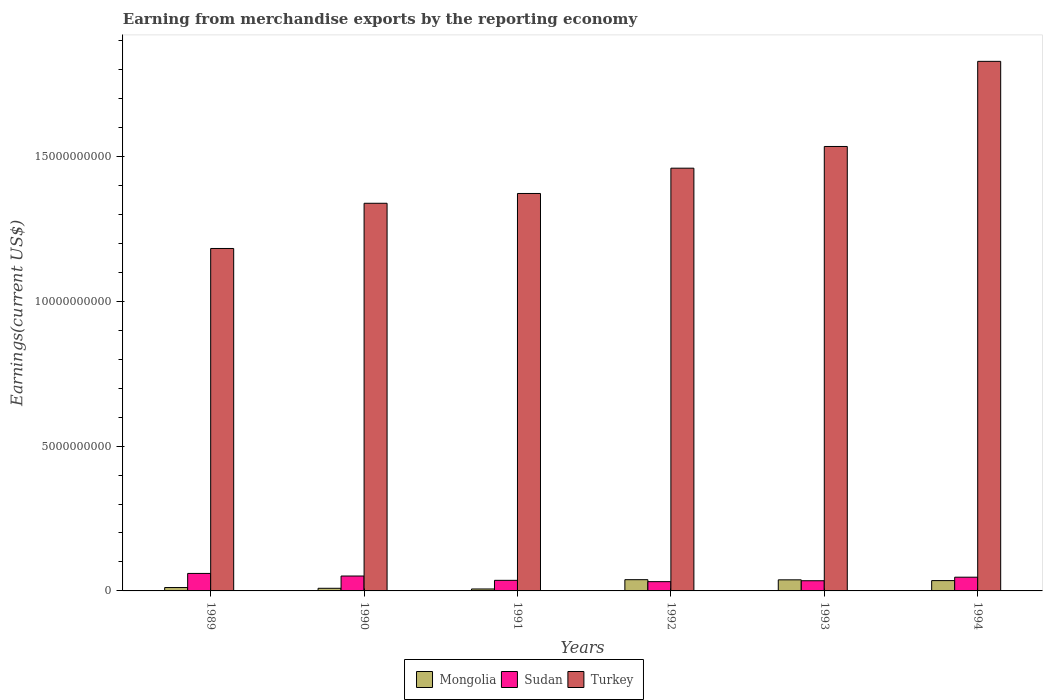How many groups of bars are there?
Keep it short and to the point. 6. Are the number of bars on each tick of the X-axis equal?
Give a very brief answer. Yes. How many bars are there on the 5th tick from the right?
Give a very brief answer. 3. In how many cases, is the number of bars for a given year not equal to the number of legend labels?
Keep it short and to the point. 0. What is the amount earned from merchandise exports in Turkey in 1991?
Offer a very short reply. 1.37e+1. Across all years, what is the maximum amount earned from merchandise exports in Turkey?
Your response must be concise. 1.83e+1. Across all years, what is the minimum amount earned from merchandise exports in Mongolia?
Your answer should be very brief. 6.74e+07. In which year was the amount earned from merchandise exports in Sudan minimum?
Keep it short and to the point. 1992. What is the total amount earned from merchandise exports in Sudan in the graph?
Make the answer very short. 2.63e+09. What is the difference between the amount earned from merchandise exports in Sudan in 1990 and that in 1994?
Provide a succinct answer. 4.06e+07. What is the difference between the amount earned from merchandise exports in Turkey in 1994 and the amount earned from merchandise exports in Sudan in 1990?
Make the answer very short. 1.78e+1. What is the average amount earned from merchandise exports in Mongolia per year?
Offer a terse response. 2.34e+08. In the year 1991, what is the difference between the amount earned from merchandise exports in Turkey and amount earned from merchandise exports in Sudan?
Offer a terse response. 1.34e+1. In how many years, is the amount earned from merchandise exports in Sudan greater than 7000000000 US$?
Make the answer very short. 0. What is the ratio of the amount earned from merchandise exports in Sudan in 1992 to that in 1994?
Your answer should be very brief. 0.68. Is the amount earned from merchandise exports in Turkey in 1991 less than that in 1992?
Ensure brevity in your answer.  Yes. What is the difference between the highest and the second highest amount earned from merchandise exports in Turkey?
Your answer should be compact. 2.94e+09. What is the difference between the highest and the lowest amount earned from merchandise exports in Sudan?
Keep it short and to the point. 2.84e+08. In how many years, is the amount earned from merchandise exports in Sudan greater than the average amount earned from merchandise exports in Sudan taken over all years?
Give a very brief answer. 3. Is the sum of the amount earned from merchandise exports in Turkey in 1990 and 1992 greater than the maximum amount earned from merchandise exports in Sudan across all years?
Keep it short and to the point. Yes. What does the 2nd bar from the right in 1992 represents?
Provide a succinct answer. Sudan. How many bars are there?
Your response must be concise. 18. How many years are there in the graph?
Your answer should be very brief. 6. Are the values on the major ticks of Y-axis written in scientific E-notation?
Offer a very short reply. No. Does the graph contain any zero values?
Offer a terse response. No. Does the graph contain grids?
Keep it short and to the point. No. Where does the legend appear in the graph?
Ensure brevity in your answer.  Bottom center. How many legend labels are there?
Provide a short and direct response. 3. How are the legend labels stacked?
Ensure brevity in your answer.  Horizontal. What is the title of the graph?
Offer a terse response. Earning from merchandise exports by the reporting economy. What is the label or title of the Y-axis?
Give a very brief answer. Earnings(current US$). What is the Earnings(current US$) of Mongolia in 1989?
Make the answer very short. 1.17e+08. What is the Earnings(current US$) in Sudan in 1989?
Ensure brevity in your answer.  6.04e+08. What is the Earnings(current US$) of Turkey in 1989?
Your response must be concise. 1.18e+1. What is the Earnings(current US$) in Mongolia in 1990?
Ensure brevity in your answer.  9.08e+07. What is the Earnings(current US$) in Sudan in 1990?
Offer a terse response. 5.15e+08. What is the Earnings(current US$) of Turkey in 1990?
Your answer should be compact. 1.34e+1. What is the Earnings(current US$) of Mongolia in 1991?
Provide a succinct answer. 6.74e+07. What is the Earnings(current US$) in Sudan in 1991?
Give a very brief answer. 3.66e+08. What is the Earnings(current US$) of Turkey in 1991?
Your answer should be compact. 1.37e+1. What is the Earnings(current US$) of Mongolia in 1992?
Keep it short and to the point. 3.88e+08. What is the Earnings(current US$) of Sudan in 1992?
Your answer should be very brief. 3.20e+08. What is the Earnings(current US$) in Turkey in 1992?
Your answer should be compact. 1.46e+1. What is the Earnings(current US$) in Mongolia in 1993?
Provide a short and direct response. 3.83e+08. What is the Earnings(current US$) in Sudan in 1993?
Provide a succinct answer. 3.52e+08. What is the Earnings(current US$) in Turkey in 1993?
Provide a succinct answer. 1.53e+1. What is the Earnings(current US$) in Mongolia in 1994?
Your answer should be compact. 3.56e+08. What is the Earnings(current US$) in Sudan in 1994?
Your response must be concise. 4.74e+08. What is the Earnings(current US$) of Turkey in 1994?
Your answer should be compact. 1.83e+1. Across all years, what is the maximum Earnings(current US$) of Mongolia?
Make the answer very short. 3.88e+08. Across all years, what is the maximum Earnings(current US$) in Sudan?
Your response must be concise. 6.04e+08. Across all years, what is the maximum Earnings(current US$) in Turkey?
Give a very brief answer. 1.83e+1. Across all years, what is the minimum Earnings(current US$) in Mongolia?
Your answer should be very brief. 6.74e+07. Across all years, what is the minimum Earnings(current US$) of Sudan?
Your answer should be compact. 3.20e+08. Across all years, what is the minimum Earnings(current US$) in Turkey?
Provide a short and direct response. 1.18e+1. What is the total Earnings(current US$) of Mongolia in the graph?
Ensure brevity in your answer.  1.40e+09. What is the total Earnings(current US$) in Sudan in the graph?
Provide a succinct answer. 2.63e+09. What is the total Earnings(current US$) of Turkey in the graph?
Give a very brief answer. 8.72e+1. What is the difference between the Earnings(current US$) in Mongolia in 1989 and that in 1990?
Give a very brief answer. 2.59e+07. What is the difference between the Earnings(current US$) in Sudan in 1989 and that in 1990?
Give a very brief answer. 8.97e+07. What is the difference between the Earnings(current US$) in Turkey in 1989 and that in 1990?
Your answer should be very brief. -1.56e+09. What is the difference between the Earnings(current US$) of Mongolia in 1989 and that in 1991?
Make the answer very short. 4.93e+07. What is the difference between the Earnings(current US$) of Sudan in 1989 and that in 1991?
Provide a succinct answer. 2.39e+08. What is the difference between the Earnings(current US$) of Turkey in 1989 and that in 1991?
Offer a very short reply. -1.90e+09. What is the difference between the Earnings(current US$) of Mongolia in 1989 and that in 1992?
Provide a succinct answer. -2.72e+08. What is the difference between the Earnings(current US$) in Sudan in 1989 and that in 1992?
Give a very brief answer. 2.84e+08. What is the difference between the Earnings(current US$) of Turkey in 1989 and that in 1992?
Offer a very short reply. -2.77e+09. What is the difference between the Earnings(current US$) in Mongolia in 1989 and that in 1993?
Your response must be concise. -2.66e+08. What is the difference between the Earnings(current US$) of Sudan in 1989 and that in 1993?
Offer a terse response. 2.52e+08. What is the difference between the Earnings(current US$) of Turkey in 1989 and that in 1993?
Offer a very short reply. -3.52e+09. What is the difference between the Earnings(current US$) of Mongolia in 1989 and that in 1994?
Make the answer very short. -2.39e+08. What is the difference between the Earnings(current US$) of Sudan in 1989 and that in 1994?
Ensure brevity in your answer.  1.30e+08. What is the difference between the Earnings(current US$) in Turkey in 1989 and that in 1994?
Offer a terse response. -6.46e+09. What is the difference between the Earnings(current US$) of Mongolia in 1990 and that in 1991?
Offer a terse response. 2.34e+07. What is the difference between the Earnings(current US$) in Sudan in 1990 and that in 1991?
Provide a succinct answer. 1.49e+08. What is the difference between the Earnings(current US$) of Turkey in 1990 and that in 1991?
Provide a short and direct response. -3.38e+08. What is the difference between the Earnings(current US$) in Mongolia in 1990 and that in 1992?
Your response must be concise. -2.98e+08. What is the difference between the Earnings(current US$) of Sudan in 1990 and that in 1992?
Your answer should be compact. 1.94e+08. What is the difference between the Earnings(current US$) in Turkey in 1990 and that in 1992?
Your answer should be very brief. -1.21e+09. What is the difference between the Earnings(current US$) of Mongolia in 1990 and that in 1993?
Your answer should be very brief. -2.92e+08. What is the difference between the Earnings(current US$) in Sudan in 1990 and that in 1993?
Offer a very short reply. 1.63e+08. What is the difference between the Earnings(current US$) of Turkey in 1990 and that in 1993?
Your answer should be compact. -1.96e+09. What is the difference between the Earnings(current US$) in Mongolia in 1990 and that in 1994?
Your answer should be compact. -2.65e+08. What is the difference between the Earnings(current US$) of Sudan in 1990 and that in 1994?
Your answer should be very brief. 4.06e+07. What is the difference between the Earnings(current US$) in Turkey in 1990 and that in 1994?
Your answer should be compact. -4.90e+09. What is the difference between the Earnings(current US$) in Mongolia in 1991 and that in 1992?
Keep it short and to the point. -3.21e+08. What is the difference between the Earnings(current US$) of Sudan in 1991 and that in 1992?
Give a very brief answer. 4.54e+07. What is the difference between the Earnings(current US$) of Turkey in 1991 and that in 1992?
Provide a succinct answer. -8.73e+08. What is the difference between the Earnings(current US$) in Mongolia in 1991 and that in 1993?
Keep it short and to the point. -3.15e+08. What is the difference between the Earnings(current US$) in Sudan in 1991 and that in 1993?
Your answer should be very brief. 1.39e+07. What is the difference between the Earnings(current US$) in Turkey in 1991 and that in 1993?
Provide a succinct answer. -1.62e+09. What is the difference between the Earnings(current US$) of Mongolia in 1991 and that in 1994?
Ensure brevity in your answer.  -2.89e+08. What is the difference between the Earnings(current US$) in Sudan in 1991 and that in 1994?
Offer a very short reply. -1.08e+08. What is the difference between the Earnings(current US$) of Turkey in 1991 and that in 1994?
Offer a terse response. -4.56e+09. What is the difference between the Earnings(current US$) in Mongolia in 1992 and that in 1993?
Offer a very short reply. 5.74e+06. What is the difference between the Earnings(current US$) in Sudan in 1992 and that in 1993?
Offer a very short reply. -3.15e+07. What is the difference between the Earnings(current US$) in Turkey in 1992 and that in 1993?
Your answer should be very brief. -7.50e+08. What is the difference between the Earnings(current US$) of Mongolia in 1992 and that in 1994?
Your answer should be very brief. 3.23e+07. What is the difference between the Earnings(current US$) in Sudan in 1992 and that in 1994?
Your answer should be compact. -1.54e+08. What is the difference between the Earnings(current US$) of Turkey in 1992 and that in 1994?
Keep it short and to the point. -3.69e+09. What is the difference between the Earnings(current US$) of Mongolia in 1993 and that in 1994?
Your response must be concise. 2.66e+07. What is the difference between the Earnings(current US$) of Sudan in 1993 and that in 1994?
Keep it short and to the point. -1.22e+08. What is the difference between the Earnings(current US$) of Turkey in 1993 and that in 1994?
Give a very brief answer. -2.94e+09. What is the difference between the Earnings(current US$) in Mongolia in 1989 and the Earnings(current US$) in Sudan in 1990?
Give a very brief answer. -3.98e+08. What is the difference between the Earnings(current US$) in Mongolia in 1989 and the Earnings(current US$) in Turkey in 1990?
Your answer should be compact. -1.33e+1. What is the difference between the Earnings(current US$) in Sudan in 1989 and the Earnings(current US$) in Turkey in 1990?
Your answer should be compact. -1.28e+1. What is the difference between the Earnings(current US$) in Mongolia in 1989 and the Earnings(current US$) in Sudan in 1991?
Your answer should be very brief. -2.49e+08. What is the difference between the Earnings(current US$) in Mongolia in 1989 and the Earnings(current US$) in Turkey in 1991?
Offer a terse response. -1.36e+1. What is the difference between the Earnings(current US$) in Sudan in 1989 and the Earnings(current US$) in Turkey in 1991?
Provide a succinct answer. -1.31e+1. What is the difference between the Earnings(current US$) of Mongolia in 1989 and the Earnings(current US$) of Sudan in 1992?
Your response must be concise. -2.04e+08. What is the difference between the Earnings(current US$) in Mongolia in 1989 and the Earnings(current US$) in Turkey in 1992?
Offer a terse response. -1.45e+1. What is the difference between the Earnings(current US$) of Sudan in 1989 and the Earnings(current US$) of Turkey in 1992?
Make the answer very short. -1.40e+1. What is the difference between the Earnings(current US$) of Mongolia in 1989 and the Earnings(current US$) of Sudan in 1993?
Provide a succinct answer. -2.35e+08. What is the difference between the Earnings(current US$) in Mongolia in 1989 and the Earnings(current US$) in Turkey in 1993?
Your answer should be very brief. -1.52e+1. What is the difference between the Earnings(current US$) of Sudan in 1989 and the Earnings(current US$) of Turkey in 1993?
Your response must be concise. -1.47e+1. What is the difference between the Earnings(current US$) of Mongolia in 1989 and the Earnings(current US$) of Sudan in 1994?
Your response must be concise. -3.57e+08. What is the difference between the Earnings(current US$) in Mongolia in 1989 and the Earnings(current US$) in Turkey in 1994?
Provide a short and direct response. -1.82e+1. What is the difference between the Earnings(current US$) of Sudan in 1989 and the Earnings(current US$) of Turkey in 1994?
Provide a short and direct response. -1.77e+1. What is the difference between the Earnings(current US$) of Mongolia in 1990 and the Earnings(current US$) of Sudan in 1991?
Provide a short and direct response. -2.75e+08. What is the difference between the Earnings(current US$) of Mongolia in 1990 and the Earnings(current US$) of Turkey in 1991?
Keep it short and to the point. -1.36e+1. What is the difference between the Earnings(current US$) in Sudan in 1990 and the Earnings(current US$) in Turkey in 1991?
Your answer should be compact. -1.32e+1. What is the difference between the Earnings(current US$) in Mongolia in 1990 and the Earnings(current US$) in Sudan in 1992?
Provide a succinct answer. -2.29e+08. What is the difference between the Earnings(current US$) of Mongolia in 1990 and the Earnings(current US$) of Turkey in 1992?
Your answer should be compact. -1.45e+1. What is the difference between the Earnings(current US$) in Sudan in 1990 and the Earnings(current US$) in Turkey in 1992?
Give a very brief answer. -1.41e+1. What is the difference between the Earnings(current US$) of Mongolia in 1990 and the Earnings(current US$) of Sudan in 1993?
Ensure brevity in your answer.  -2.61e+08. What is the difference between the Earnings(current US$) of Mongolia in 1990 and the Earnings(current US$) of Turkey in 1993?
Offer a very short reply. -1.53e+1. What is the difference between the Earnings(current US$) in Sudan in 1990 and the Earnings(current US$) in Turkey in 1993?
Offer a very short reply. -1.48e+1. What is the difference between the Earnings(current US$) in Mongolia in 1990 and the Earnings(current US$) in Sudan in 1994?
Keep it short and to the point. -3.83e+08. What is the difference between the Earnings(current US$) of Mongolia in 1990 and the Earnings(current US$) of Turkey in 1994?
Your response must be concise. -1.82e+1. What is the difference between the Earnings(current US$) in Sudan in 1990 and the Earnings(current US$) in Turkey in 1994?
Your response must be concise. -1.78e+1. What is the difference between the Earnings(current US$) in Mongolia in 1991 and the Earnings(current US$) in Sudan in 1992?
Your response must be concise. -2.53e+08. What is the difference between the Earnings(current US$) in Mongolia in 1991 and the Earnings(current US$) in Turkey in 1992?
Keep it short and to the point. -1.45e+1. What is the difference between the Earnings(current US$) of Sudan in 1991 and the Earnings(current US$) of Turkey in 1992?
Provide a succinct answer. -1.42e+1. What is the difference between the Earnings(current US$) of Mongolia in 1991 and the Earnings(current US$) of Sudan in 1993?
Make the answer very short. -2.84e+08. What is the difference between the Earnings(current US$) in Mongolia in 1991 and the Earnings(current US$) in Turkey in 1993?
Offer a terse response. -1.53e+1. What is the difference between the Earnings(current US$) of Sudan in 1991 and the Earnings(current US$) of Turkey in 1993?
Make the answer very short. -1.50e+1. What is the difference between the Earnings(current US$) in Mongolia in 1991 and the Earnings(current US$) in Sudan in 1994?
Offer a terse response. -4.07e+08. What is the difference between the Earnings(current US$) of Mongolia in 1991 and the Earnings(current US$) of Turkey in 1994?
Your response must be concise. -1.82e+1. What is the difference between the Earnings(current US$) in Sudan in 1991 and the Earnings(current US$) in Turkey in 1994?
Your answer should be compact. -1.79e+1. What is the difference between the Earnings(current US$) in Mongolia in 1992 and the Earnings(current US$) in Sudan in 1993?
Your response must be concise. 3.67e+07. What is the difference between the Earnings(current US$) of Mongolia in 1992 and the Earnings(current US$) of Turkey in 1993?
Provide a short and direct response. -1.50e+1. What is the difference between the Earnings(current US$) of Sudan in 1992 and the Earnings(current US$) of Turkey in 1993?
Your response must be concise. -1.50e+1. What is the difference between the Earnings(current US$) in Mongolia in 1992 and the Earnings(current US$) in Sudan in 1994?
Keep it short and to the point. -8.55e+07. What is the difference between the Earnings(current US$) in Mongolia in 1992 and the Earnings(current US$) in Turkey in 1994?
Provide a short and direct response. -1.79e+1. What is the difference between the Earnings(current US$) in Sudan in 1992 and the Earnings(current US$) in Turkey in 1994?
Provide a succinct answer. -1.80e+1. What is the difference between the Earnings(current US$) in Mongolia in 1993 and the Earnings(current US$) in Sudan in 1994?
Ensure brevity in your answer.  -9.13e+07. What is the difference between the Earnings(current US$) of Mongolia in 1993 and the Earnings(current US$) of Turkey in 1994?
Provide a succinct answer. -1.79e+1. What is the difference between the Earnings(current US$) in Sudan in 1993 and the Earnings(current US$) in Turkey in 1994?
Offer a very short reply. -1.79e+1. What is the average Earnings(current US$) in Mongolia per year?
Give a very brief answer. 2.34e+08. What is the average Earnings(current US$) in Sudan per year?
Give a very brief answer. 4.38e+08. What is the average Earnings(current US$) in Turkey per year?
Your answer should be compact. 1.45e+1. In the year 1989, what is the difference between the Earnings(current US$) in Mongolia and Earnings(current US$) in Sudan?
Provide a succinct answer. -4.87e+08. In the year 1989, what is the difference between the Earnings(current US$) in Mongolia and Earnings(current US$) in Turkey?
Your answer should be compact. -1.17e+1. In the year 1989, what is the difference between the Earnings(current US$) of Sudan and Earnings(current US$) of Turkey?
Your response must be concise. -1.12e+1. In the year 1990, what is the difference between the Earnings(current US$) in Mongolia and Earnings(current US$) in Sudan?
Provide a short and direct response. -4.24e+08. In the year 1990, what is the difference between the Earnings(current US$) in Mongolia and Earnings(current US$) in Turkey?
Ensure brevity in your answer.  -1.33e+1. In the year 1990, what is the difference between the Earnings(current US$) in Sudan and Earnings(current US$) in Turkey?
Provide a succinct answer. -1.29e+1. In the year 1991, what is the difference between the Earnings(current US$) of Mongolia and Earnings(current US$) of Sudan?
Your response must be concise. -2.98e+08. In the year 1991, what is the difference between the Earnings(current US$) in Mongolia and Earnings(current US$) in Turkey?
Your response must be concise. -1.37e+1. In the year 1991, what is the difference between the Earnings(current US$) of Sudan and Earnings(current US$) of Turkey?
Provide a short and direct response. -1.34e+1. In the year 1992, what is the difference between the Earnings(current US$) of Mongolia and Earnings(current US$) of Sudan?
Ensure brevity in your answer.  6.82e+07. In the year 1992, what is the difference between the Earnings(current US$) in Mongolia and Earnings(current US$) in Turkey?
Make the answer very short. -1.42e+1. In the year 1992, what is the difference between the Earnings(current US$) in Sudan and Earnings(current US$) in Turkey?
Ensure brevity in your answer.  -1.43e+1. In the year 1993, what is the difference between the Earnings(current US$) of Mongolia and Earnings(current US$) of Sudan?
Your response must be concise. 3.09e+07. In the year 1993, what is the difference between the Earnings(current US$) of Mongolia and Earnings(current US$) of Turkey?
Provide a short and direct response. -1.50e+1. In the year 1993, what is the difference between the Earnings(current US$) of Sudan and Earnings(current US$) of Turkey?
Provide a succinct answer. -1.50e+1. In the year 1994, what is the difference between the Earnings(current US$) of Mongolia and Earnings(current US$) of Sudan?
Your response must be concise. -1.18e+08. In the year 1994, what is the difference between the Earnings(current US$) of Mongolia and Earnings(current US$) of Turkey?
Your response must be concise. -1.79e+1. In the year 1994, what is the difference between the Earnings(current US$) in Sudan and Earnings(current US$) in Turkey?
Provide a short and direct response. -1.78e+1. What is the ratio of the Earnings(current US$) of Mongolia in 1989 to that in 1990?
Your answer should be compact. 1.29. What is the ratio of the Earnings(current US$) of Sudan in 1989 to that in 1990?
Your answer should be very brief. 1.17. What is the ratio of the Earnings(current US$) in Turkey in 1989 to that in 1990?
Offer a very short reply. 0.88. What is the ratio of the Earnings(current US$) in Mongolia in 1989 to that in 1991?
Ensure brevity in your answer.  1.73. What is the ratio of the Earnings(current US$) of Sudan in 1989 to that in 1991?
Your answer should be compact. 1.65. What is the ratio of the Earnings(current US$) of Turkey in 1989 to that in 1991?
Your answer should be very brief. 0.86. What is the ratio of the Earnings(current US$) in Mongolia in 1989 to that in 1992?
Provide a succinct answer. 0.3. What is the ratio of the Earnings(current US$) of Sudan in 1989 to that in 1992?
Provide a short and direct response. 1.89. What is the ratio of the Earnings(current US$) of Turkey in 1989 to that in 1992?
Make the answer very short. 0.81. What is the ratio of the Earnings(current US$) of Mongolia in 1989 to that in 1993?
Make the answer very short. 0.3. What is the ratio of the Earnings(current US$) of Sudan in 1989 to that in 1993?
Offer a terse response. 1.72. What is the ratio of the Earnings(current US$) in Turkey in 1989 to that in 1993?
Offer a terse response. 0.77. What is the ratio of the Earnings(current US$) of Mongolia in 1989 to that in 1994?
Your answer should be compact. 0.33. What is the ratio of the Earnings(current US$) in Sudan in 1989 to that in 1994?
Offer a very short reply. 1.27. What is the ratio of the Earnings(current US$) in Turkey in 1989 to that in 1994?
Make the answer very short. 0.65. What is the ratio of the Earnings(current US$) of Mongolia in 1990 to that in 1991?
Offer a terse response. 1.35. What is the ratio of the Earnings(current US$) of Sudan in 1990 to that in 1991?
Provide a short and direct response. 1.41. What is the ratio of the Earnings(current US$) of Turkey in 1990 to that in 1991?
Your answer should be compact. 0.98. What is the ratio of the Earnings(current US$) of Mongolia in 1990 to that in 1992?
Keep it short and to the point. 0.23. What is the ratio of the Earnings(current US$) of Sudan in 1990 to that in 1992?
Your answer should be very brief. 1.61. What is the ratio of the Earnings(current US$) in Turkey in 1990 to that in 1992?
Your response must be concise. 0.92. What is the ratio of the Earnings(current US$) in Mongolia in 1990 to that in 1993?
Ensure brevity in your answer.  0.24. What is the ratio of the Earnings(current US$) in Sudan in 1990 to that in 1993?
Give a very brief answer. 1.46. What is the ratio of the Earnings(current US$) of Turkey in 1990 to that in 1993?
Your answer should be very brief. 0.87. What is the ratio of the Earnings(current US$) in Mongolia in 1990 to that in 1994?
Provide a succinct answer. 0.26. What is the ratio of the Earnings(current US$) of Sudan in 1990 to that in 1994?
Provide a succinct answer. 1.09. What is the ratio of the Earnings(current US$) of Turkey in 1990 to that in 1994?
Provide a short and direct response. 0.73. What is the ratio of the Earnings(current US$) in Mongolia in 1991 to that in 1992?
Ensure brevity in your answer.  0.17. What is the ratio of the Earnings(current US$) in Sudan in 1991 to that in 1992?
Offer a very short reply. 1.14. What is the ratio of the Earnings(current US$) in Turkey in 1991 to that in 1992?
Your response must be concise. 0.94. What is the ratio of the Earnings(current US$) of Mongolia in 1991 to that in 1993?
Provide a succinct answer. 0.18. What is the ratio of the Earnings(current US$) of Sudan in 1991 to that in 1993?
Keep it short and to the point. 1.04. What is the ratio of the Earnings(current US$) of Turkey in 1991 to that in 1993?
Your answer should be compact. 0.89. What is the ratio of the Earnings(current US$) of Mongolia in 1991 to that in 1994?
Offer a terse response. 0.19. What is the ratio of the Earnings(current US$) in Sudan in 1991 to that in 1994?
Offer a very short reply. 0.77. What is the ratio of the Earnings(current US$) of Turkey in 1991 to that in 1994?
Give a very brief answer. 0.75. What is the ratio of the Earnings(current US$) in Mongolia in 1992 to that in 1993?
Your response must be concise. 1.01. What is the ratio of the Earnings(current US$) in Sudan in 1992 to that in 1993?
Your response must be concise. 0.91. What is the ratio of the Earnings(current US$) in Turkey in 1992 to that in 1993?
Your response must be concise. 0.95. What is the ratio of the Earnings(current US$) in Mongolia in 1992 to that in 1994?
Your answer should be compact. 1.09. What is the ratio of the Earnings(current US$) of Sudan in 1992 to that in 1994?
Provide a short and direct response. 0.68. What is the ratio of the Earnings(current US$) in Turkey in 1992 to that in 1994?
Offer a terse response. 0.8. What is the ratio of the Earnings(current US$) of Mongolia in 1993 to that in 1994?
Offer a terse response. 1.07. What is the ratio of the Earnings(current US$) in Sudan in 1993 to that in 1994?
Ensure brevity in your answer.  0.74. What is the ratio of the Earnings(current US$) of Turkey in 1993 to that in 1994?
Offer a terse response. 0.84. What is the difference between the highest and the second highest Earnings(current US$) of Mongolia?
Provide a short and direct response. 5.74e+06. What is the difference between the highest and the second highest Earnings(current US$) of Sudan?
Make the answer very short. 8.97e+07. What is the difference between the highest and the second highest Earnings(current US$) in Turkey?
Your answer should be compact. 2.94e+09. What is the difference between the highest and the lowest Earnings(current US$) of Mongolia?
Your answer should be compact. 3.21e+08. What is the difference between the highest and the lowest Earnings(current US$) of Sudan?
Provide a short and direct response. 2.84e+08. What is the difference between the highest and the lowest Earnings(current US$) of Turkey?
Your answer should be very brief. 6.46e+09. 